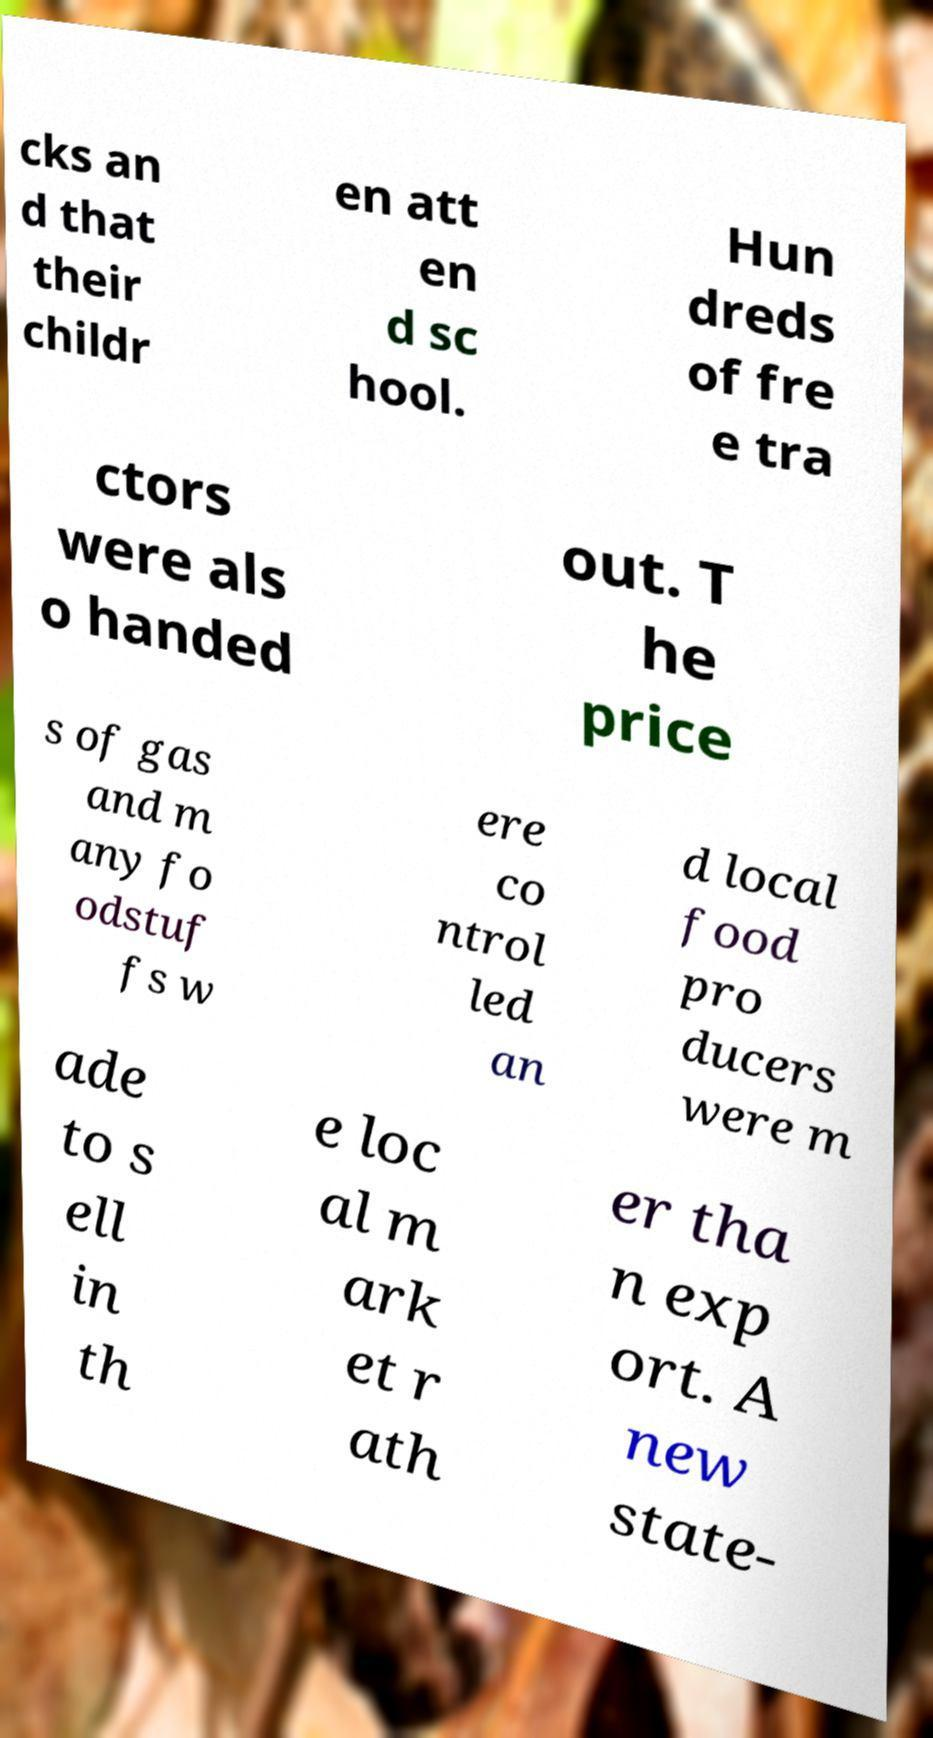There's text embedded in this image that I need extracted. Can you transcribe it verbatim? cks an d that their childr en att en d sc hool. Hun dreds of fre e tra ctors were als o handed out. T he price s of gas and m any fo odstuf fs w ere co ntrol led an d local food pro ducers were m ade to s ell in th e loc al m ark et r ath er tha n exp ort. A new state- 